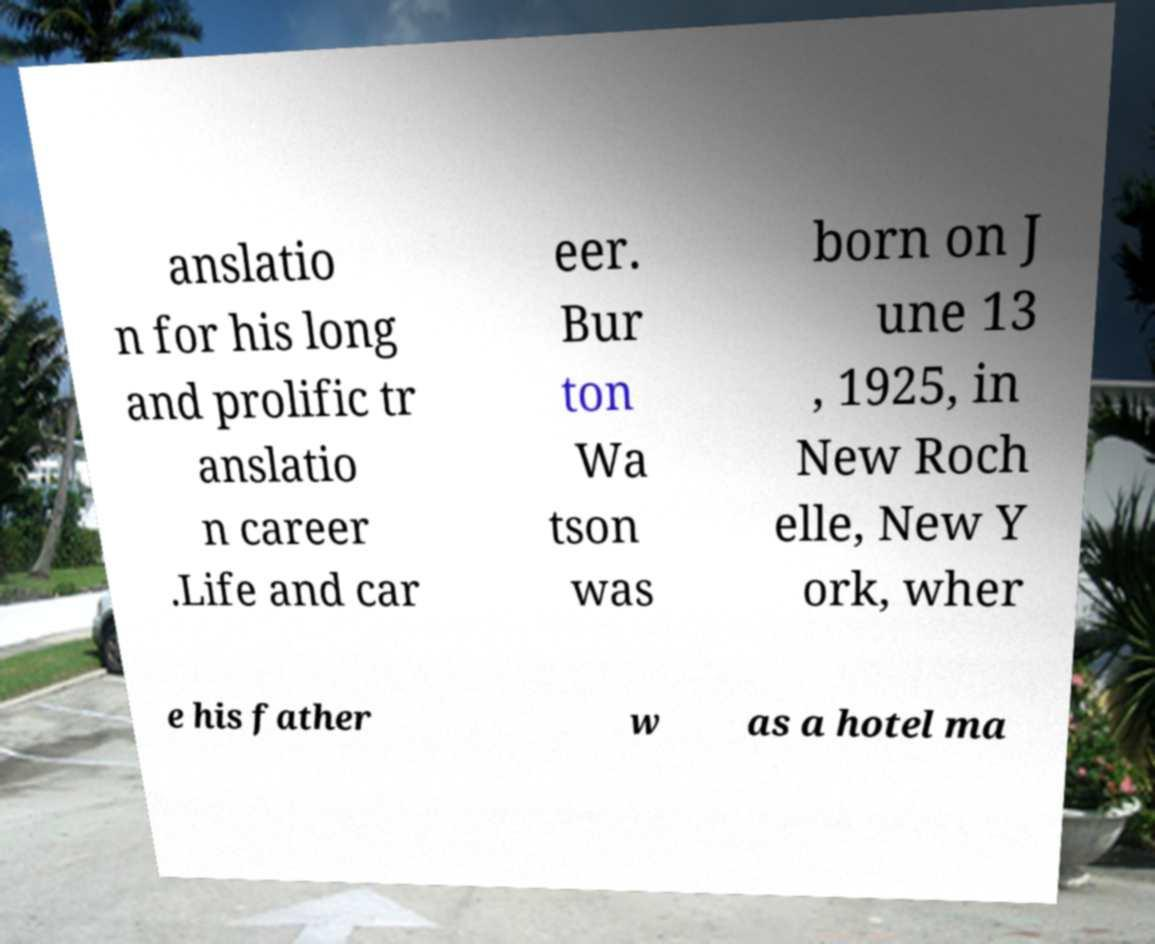What messages or text are displayed in this image? I need them in a readable, typed format. anslatio n for his long and prolific tr anslatio n career .Life and car eer. Bur ton Wa tson was born on J une 13 , 1925, in New Roch elle, New Y ork, wher e his father w as a hotel ma 